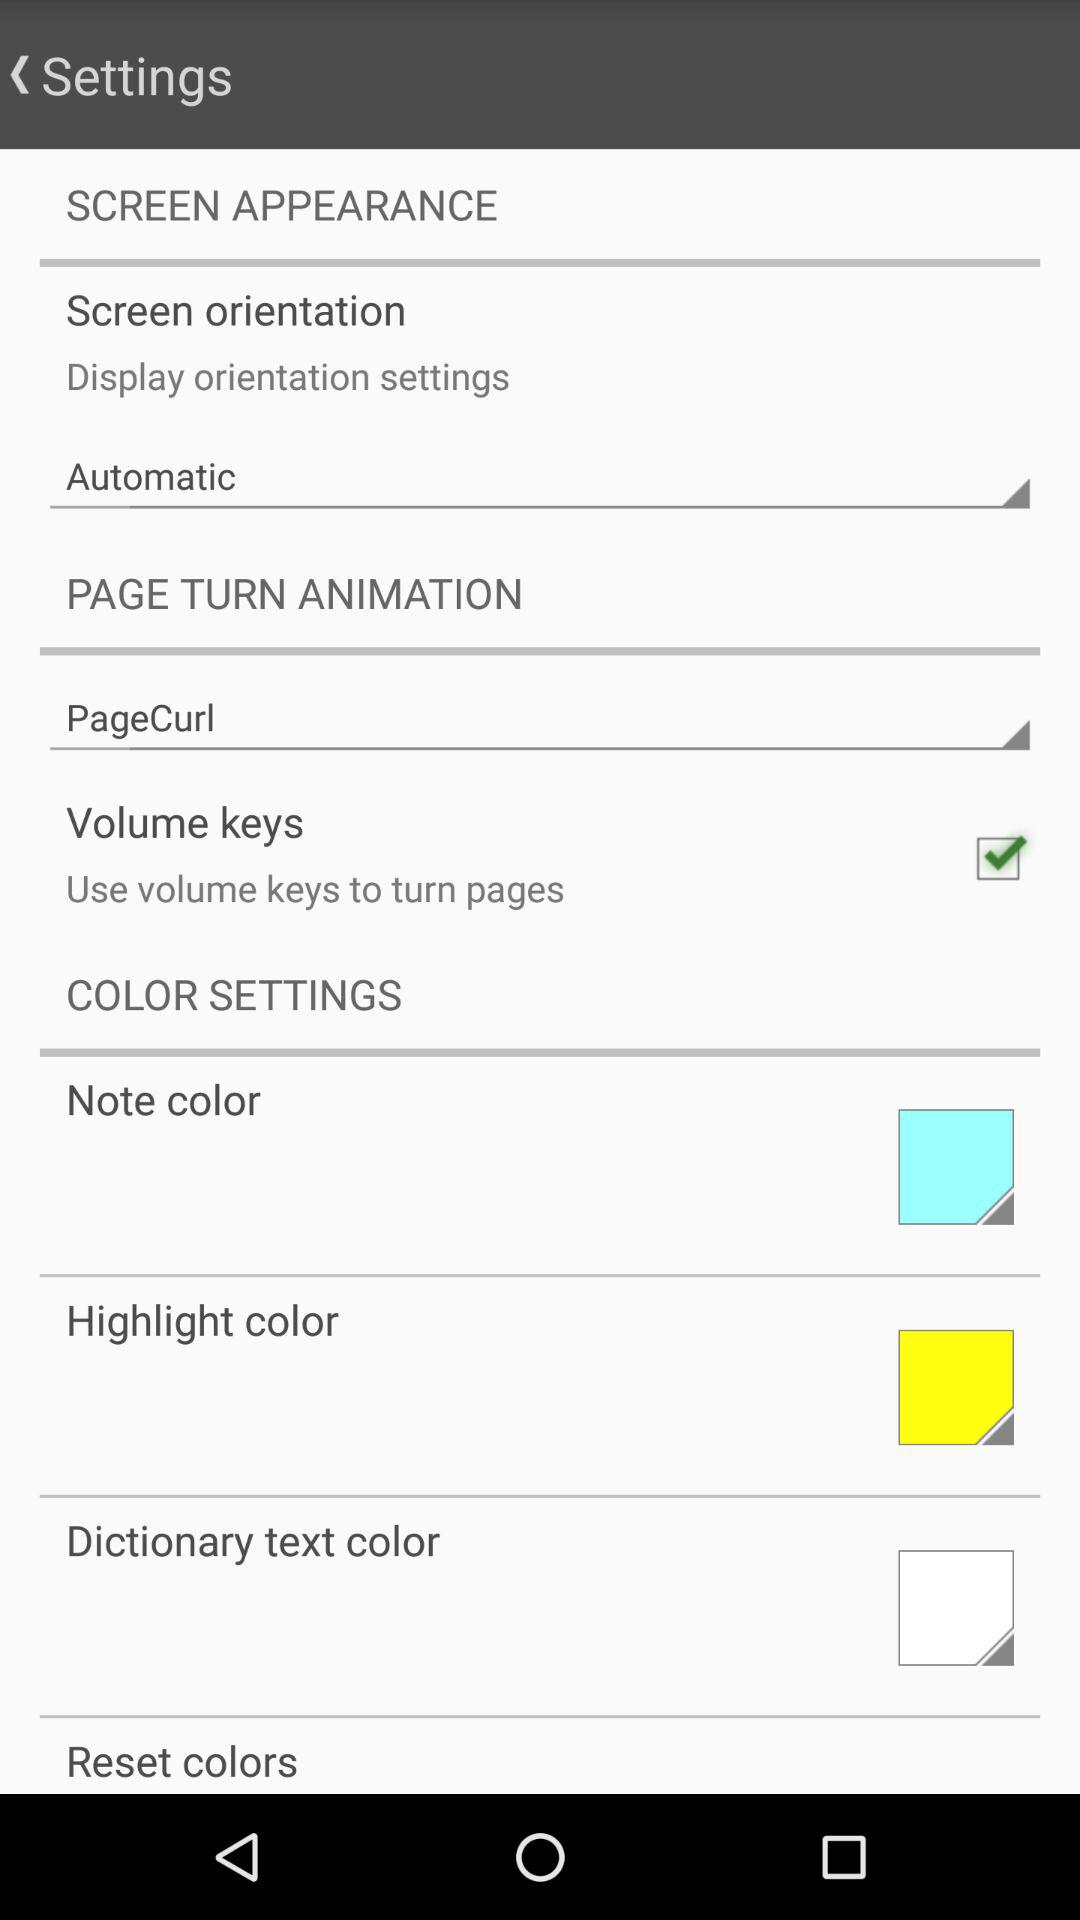What is the status of "Volume keys"? The status is "on". 